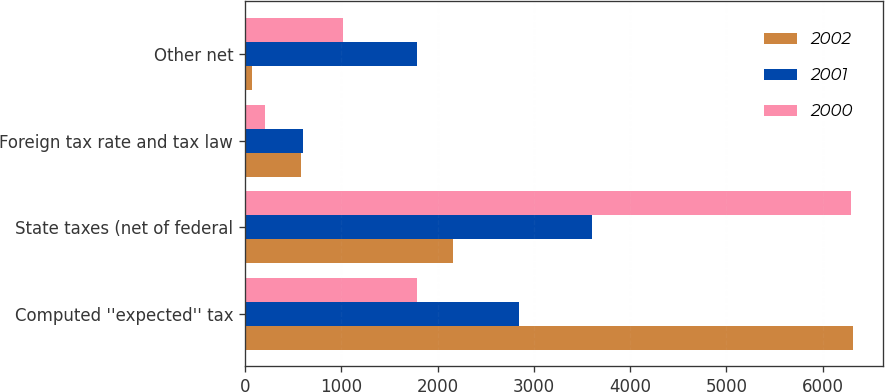Convert chart to OTSL. <chart><loc_0><loc_0><loc_500><loc_500><stacked_bar_chart><ecel><fcel>Computed ''expected'' tax<fcel>State taxes (net of federal<fcel>Foreign tax rate and tax law<fcel>Other net<nl><fcel>2002<fcel>6311<fcel>2157<fcel>586<fcel>70<nl><fcel>2001<fcel>2846<fcel>3601<fcel>598<fcel>1785<nl><fcel>2000<fcel>1785<fcel>6297<fcel>209<fcel>1015<nl></chart> 